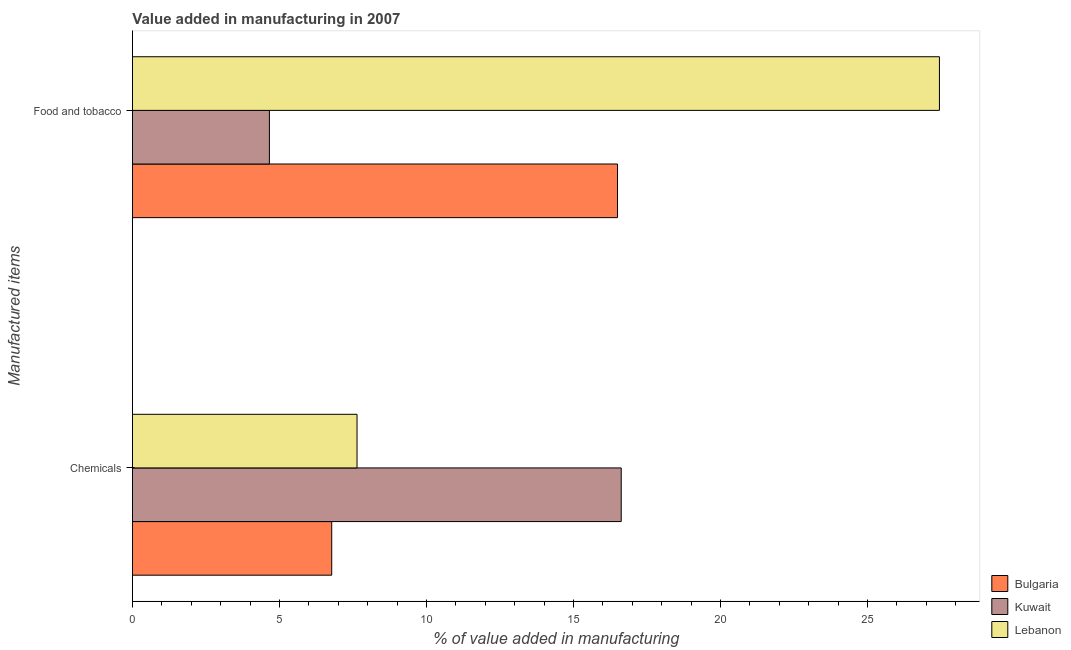How many bars are there on the 2nd tick from the bottom?
Your answer should be very brief. 3. What is the label of the 2nd group of bars from the top?
Offer a very short reply. Chemicals. What is the value added by  manufacturing chemicals in Bulgaria?
Give a very brief answer. 6.78. Across all countries, what is the maximum value added by  manufacturing chemicals?
Your answer should be compact. 16.62. Across all countries, what is the minimum value added by  manufacturing chemicals?
Your answer should be compact. 6.78. In which country was the value added by manufacturing food and tobacco maximum?
Provide a succinct answer. Lebanon. In which country was the value added by manufacturing food and tobacco minimum?
Offer a very short reply. Kuwait. What is the total value added by manufacturing food and tobacco in the graph?
Your answer should be very brief. 48.6. What is the difference between the value added by  manufacturing chemicals in Lebanon and that in Kuwait?
Offer a very short reply. -8.98. What is the difference between the value added by manufacturing food and tobacco in Bulgaria and the value added by  manufacturing chemicals in Lebanon?
Keep it short and to the point. 8.86. What is the average value added by manufacturing food and tobacco per country?
Provide a succinct answer. 16.2. What is the difference between the value added by  manufacturing chemicals and value added by manufacturing food and tobacco in Kuwait?
Provide a succinct answer. 11.96. In how many countries, is the value added by manufacturing food and tobacco greater than 21 %?
Provide a short and direct response. 1. What is the ratio of the value added by  manufacturing chemicals in Bulgaria to that in Lebanon?
Your response must be concise. 0.89. In how many countries, is the value added by manufacturing food and tobacco greater than the average value added by manufacturing food and tobacco taken over all countries?
Offer a terse response. 2. What does the 2nd bar from the top in Chemicals represents?
Offer a very short reply. Kuwait. What does the 3rd bar from the bottom in Food and tobacco represents?
Keep it short and to the point. Lebanon. What is the difference between two consecutive major ticks on the X-axis?
Provide a succinct answer. 5. Are the values on the major ticks of X-axis written in scientific E-notation?
Offer a terse response. No. How many legend labels are there?
Provide a short and direct response. 3. How are the legend labels stacked?
Keep it short and to the point. Vertical. What is the title of the graph?
Offer a very short reply. Value added in manufacturing in 2007. What is the label or title of the X-axis?
Make the answer very short. % of value added in manufacturing. What is the label or title of the Y-axis?
Keep it short and to the point. Manufactured items. What is the % of value added in manufacturing in Bulgaria in Chemicals?
Your answer should be very brief. 6.78. What is the % of value added in manufacturing of Kuwait in Chemicals?
Provide a short and direct response. 16.62. What is the % of value added in manufacturing of Lebanon in Chemicals?
Your answer should be very brief. 7.64. What is the % of value added in manufacturing in Bulgaria in Food and tobacco?
Provide a succinct answer. 16.5. What is the % of value added in manufacturing in Kuwait in Food and tobacco?
Make the answer very short. 4.66. What is the % of value added in manufacturing of Lebanon in Food and tobacco?
Offer a very short reply. 27.45. Across all Manufactured items, what is the maximum % of value added in manufacturing of Bulgaria?
Your answer should be compact. 16.5. Across all Manufactured items, what is the maximum % of value added in manufacturing in Kuwait?
Your answer should be very brief. 16.62. Across all Manufactured items, what is the maximum % of value added in manufacturing of Lebanon?
Offer a terse response. 27.45. Across all Manufactured items, what is the minimum % of value added in manufacturing in Bulgaria?
Make the answer very short. 6.78. Across all Manufactured items, what is the minimum % of value added in manufacturing in Kuwait?
Offer a very short reply. 4.66. Across all Manufactured items, what is the minimum % of value added in manufacturing in Lebanon?
Provide a succinct answer. 7.64. What is the total % of value added in manufacturing of Bulgaria in the graph?
Provide a short and direct response. 23.28. What is the total % of value added in manufacturing in Kuwait in the graph?
Give a very brief answer. 21.28. What is the total % of value added in manufacturing of Lebanon in the graph?
Your answer should be very brief. 35.08. What is the difference between the % of value added in manufacturing in Bulgaria in Chemicals and that in Food and tobacco?
Offer a very short reply. -9.72. What is the difference between the % of value added in manufacturing in Kuwait in Chemicals and that in Food and tobacco?
Your answer should be compact. 11.96. What is the difference between the % of value added in manufacturing of Lebanon in Chemicals and that in Food and tobacco?
Offer a very short reply. -19.81. What is the difference between the % of value added in manufacturing in Bulgaria in Chemicals and the % of value added in manufacturing in Kuwait in Food and tobacco?
Give a very brief answer. 2.12. What is the difference between the % of value added in manufacturing of Bulgaria in Chemicals and the % of value added in manufacturing of Lebanon in Food and tobacco?
Your answer should be compact. -20.67. What is the difference between the % of value added in manufacturing in Kuwait in Chemicals and the % of value added in manufacturing in Lebanon in Food and tobacco?
Give a very brief answer. -10.82. What is the average % of value added in manufacturing in Bulgaria per Manufactured items?
Provide a succinct answer. 11.64. What is the average % of value added in manufacturing of Kuwait per Manufactured items?
Your response must be concise. 10.64. What is the average % of value added in manufacturing of Lebanon per Manufactured items?
Provide a succinct answer. 17.54. What is the difference between the % of value added in manufacturing of Bulgaria and % of value added in manufacturing of Kuwait in Chemicals?
Offer a very short reply. -9.85. What is the difference between the % of value added in manufacturing in Bulgaria and % of value added in manufacturing in Lebanon in Chemicals?
Provide a succinct answer. -0.86. What is the difference between the % of value added in manufacturing in Kuwait and % of value added in manufacturing in Lebanon in Chemicals?
Make the answer very short. 8.98. What is the difference between the % of value added in manufacturing in Bulgaria and % of value added in manufacturing in Kuwait in Food and tobacco?
Your answer should be very brief. 11.84. What is the difference between the % of value added in manufacturing in Bulgaria and % of value added in manufacturing in Lebanon in Food and tobacco?
Offer a very short reply. -10.95. What is the difference between the % of value added in manufacturing of Kuwait and % of value added in manufacturing of Lebanon in Food and tobacco?
Make the answer very short. -22.79. What is the ratio of the % of value added in manufacturing in Bulgaria in Chemicals to that in Food and tobacco?
Offer a terse response. 0.41. What is the ratio of the % of value added in manufacturing of Kuwait in Chemicals to that in Food and tobacco?
Provide a succinct answer. 3.57. What is the ratio of the % of value added in manufacturing in Lebanon in Chemicals to that in Food and tobacco?
Your answer should be very brief. 0.28. What is the difference between the highest and the second highest % of value added in manufacturing in Bulgaria?
Ensure brevity in your answer.  9.72. What is the difference between the highest and the second highest % of value added in manufacturing in Kuwait?
Ensure brevity in your answer.  11.96. What is the difference between the highest and the second highest % of value added in manufacturing of Lebanon?
Ensure brevity in your answer.  19.81. What is the difference between the highest and the lowest % of value added in manufacturing in Bulgaria?
Offer a terse response. 9.72. What is the difference between the highest and the lowest % of value added in manufacturing in Kuwait?
Offer a very short reply. 11.96. What is the difference between the highest and the lowest % of value added in manufacturing in Lebanon?
Offer a terse response. 19.81. 